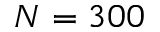<formula> <loc_0><loc_0><loc_500><loc_500>N = 3 0 0</formula> 